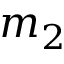Convert formula to latex. <formula><loc_0><loc_0><loc_500><loc_500>m _ { 2 }</formula> 